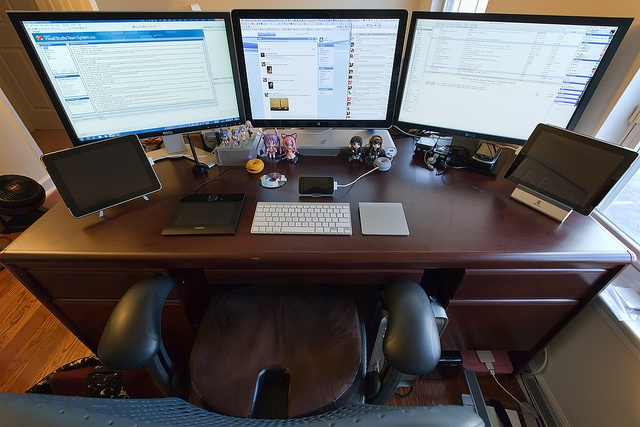Describe the objects in this image and their specific colors. I can see chair in maroon, black, blue, and darkblue tones, tv in maroon, lightblue, black, and gray tones, tv in maroon, lightgray, black, lightblue, and gray tones, tv in maroon, lavender, black, and lightblue tones, and keyboard in maroon, darkgray, lightgray, and gray tones in this image. 